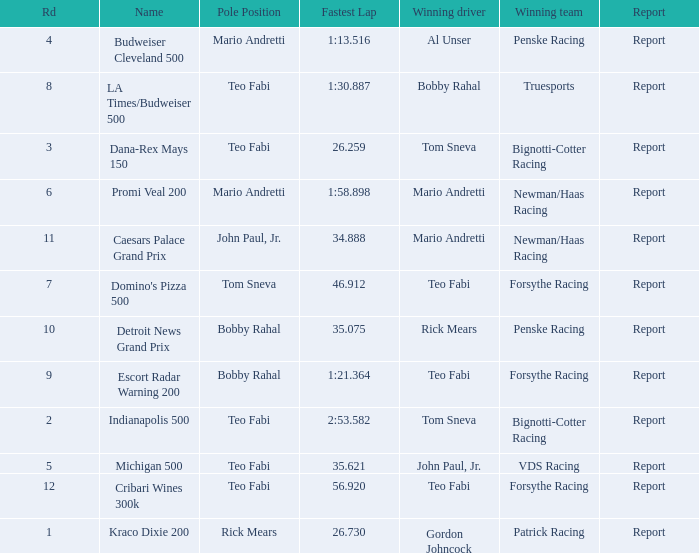What was the fastest lap time in the Escort Radar Warning 200? 1:21.364. 